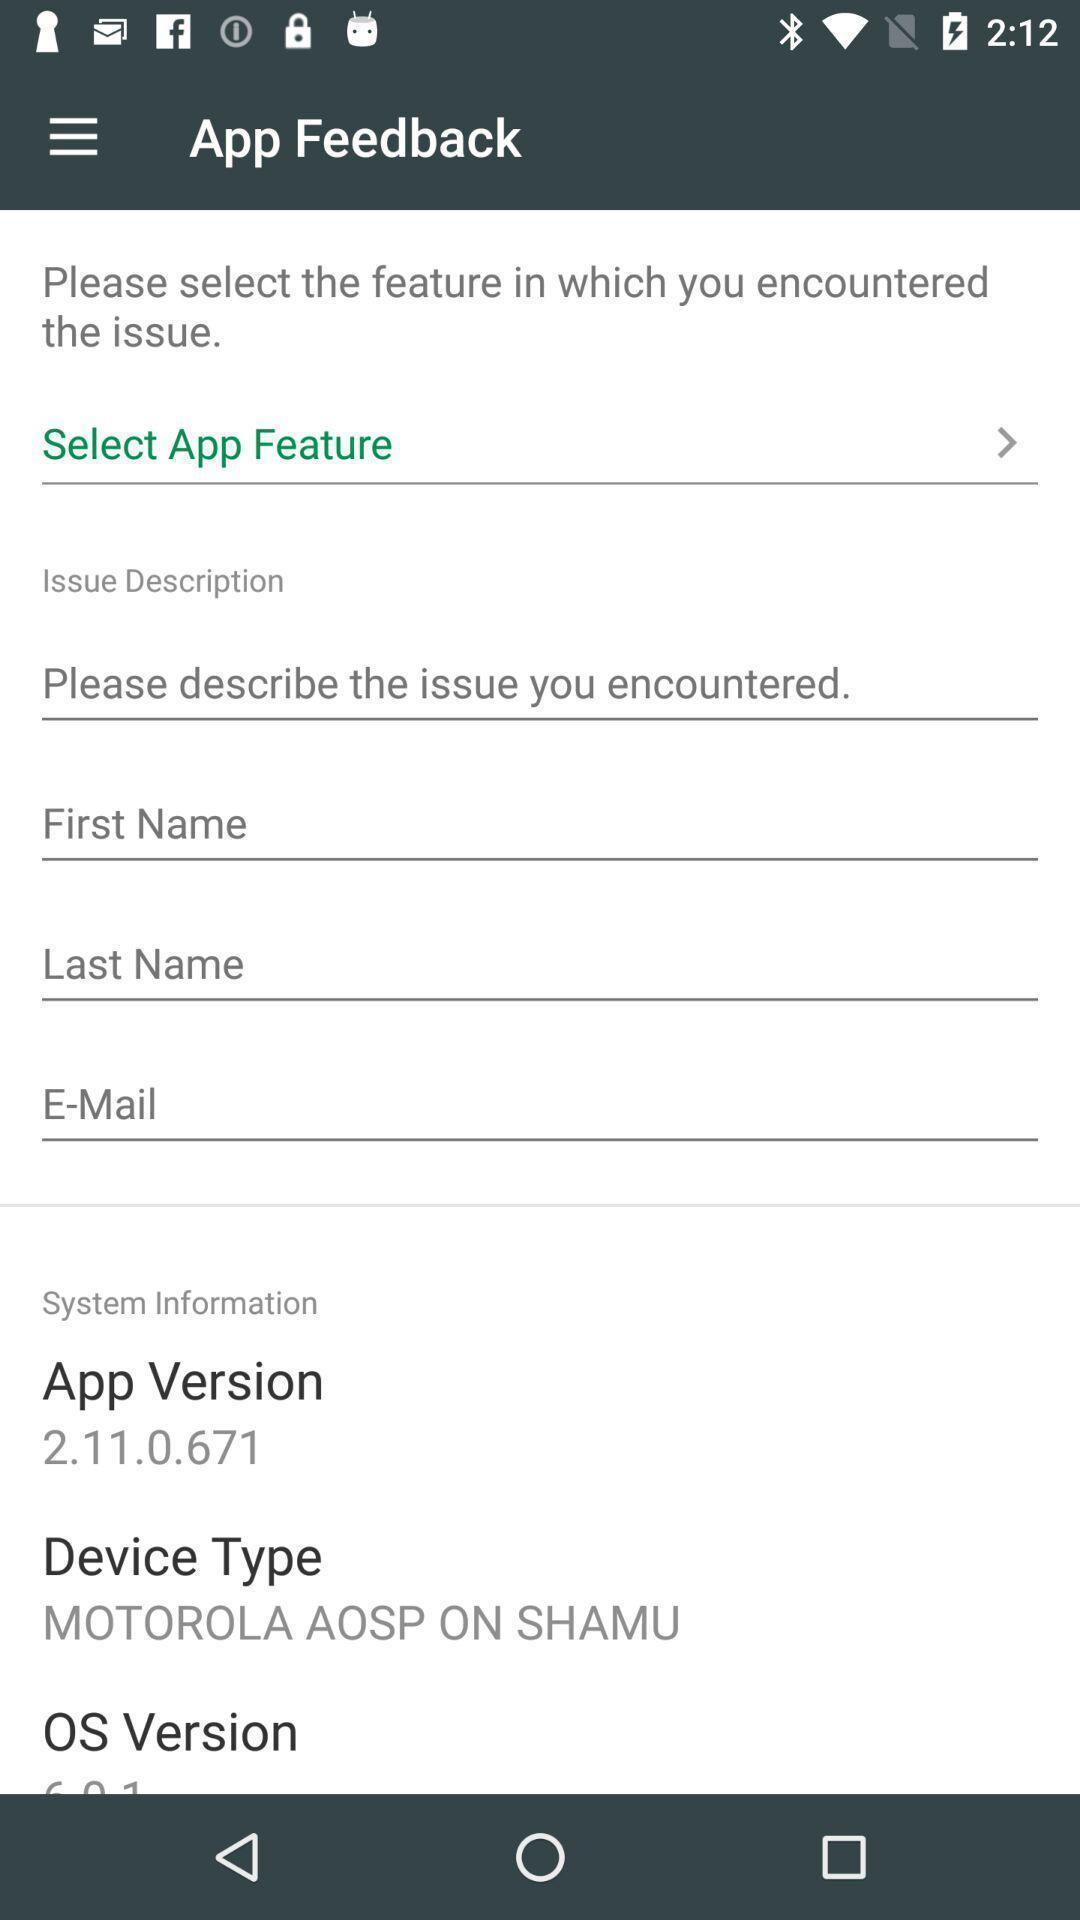Describe this image in words. Screen shows feedback details. 